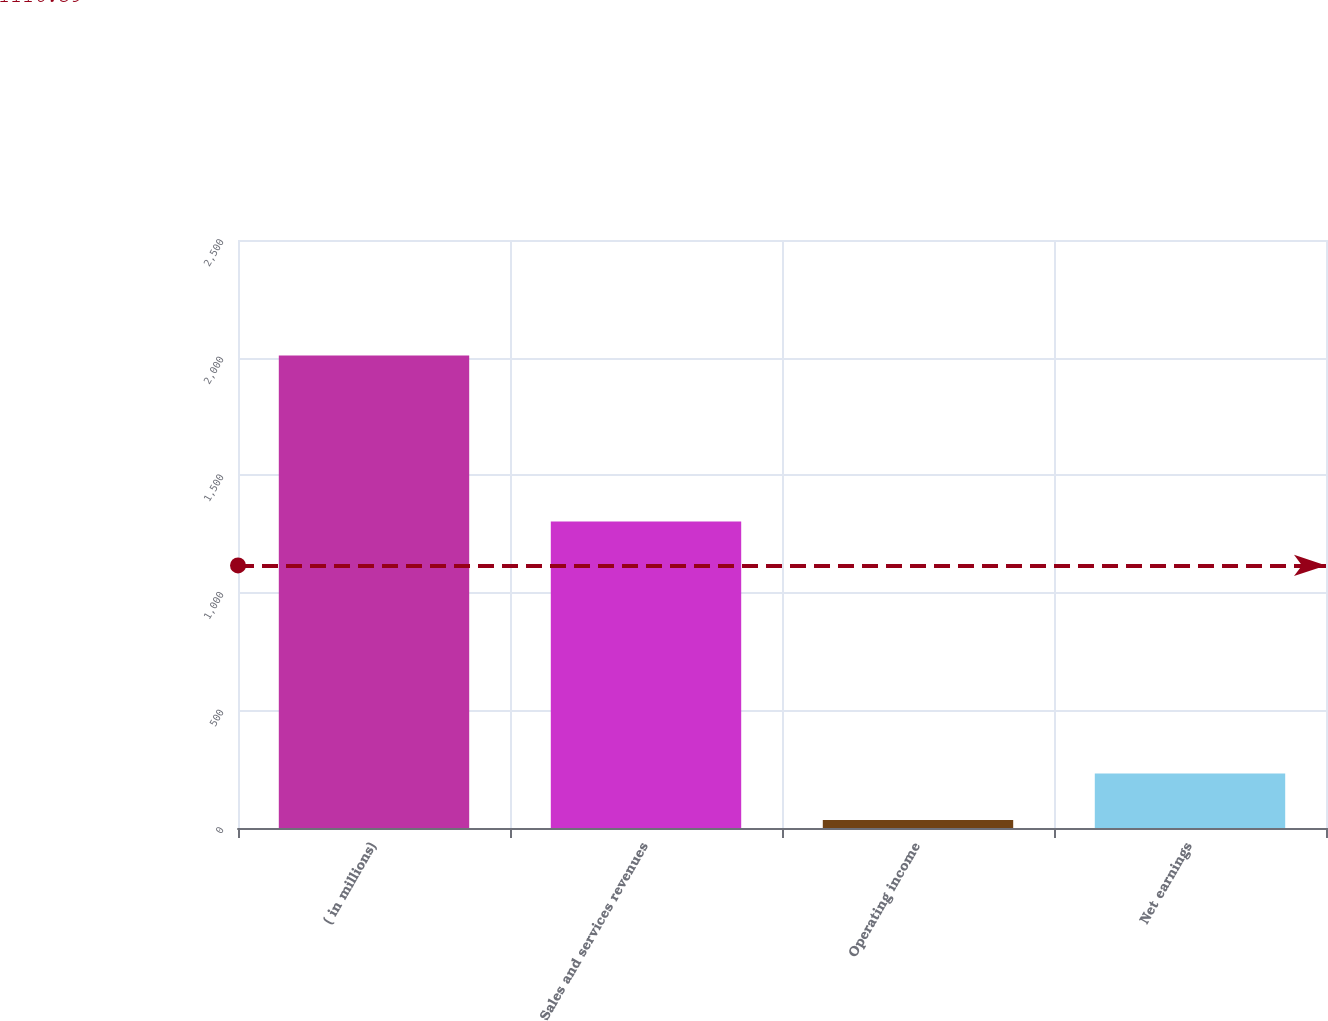<chart> <loc_0><loc_0><loc_500><loc_500><bar_chart><fcel>( in millions)<fcel>Sales and services revenues<fcel>Operating income<fcel>Net earnings<nl><fcel>2009<fcel>1303<fcel>34<fcel>231.5<nl></chart> 